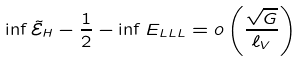Convert formula to latex. <formula><loc_0><loc_0><loc_500><loc_500>\inf \tilde { \mathcal { E } } _ { H } - \frac { 1 } { 2 } - \inf E _ { L L L } = o \left ( \frac { \sqrt { G } } { \ell _ { V } } \right )</formula> 